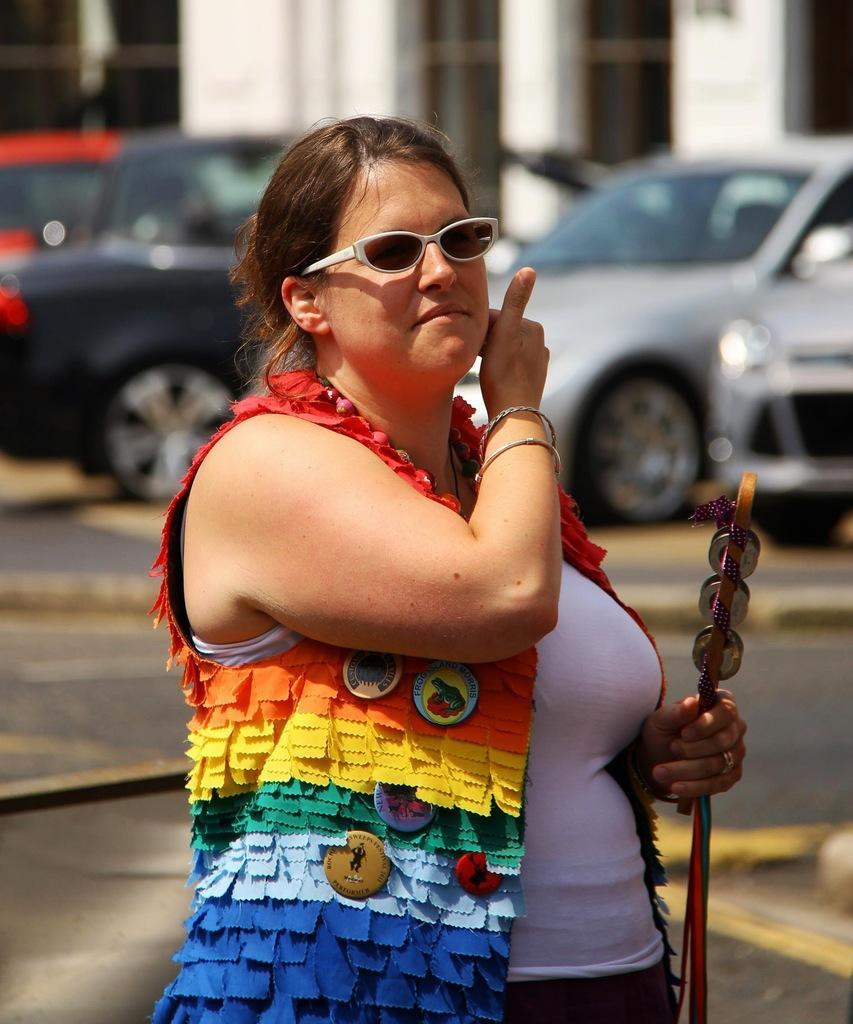Please provide a concise description of this image. This picture is clicked outside. In the foreground there is a woman holding an object and seems to be walking. In the background we can see the building and the cars. 